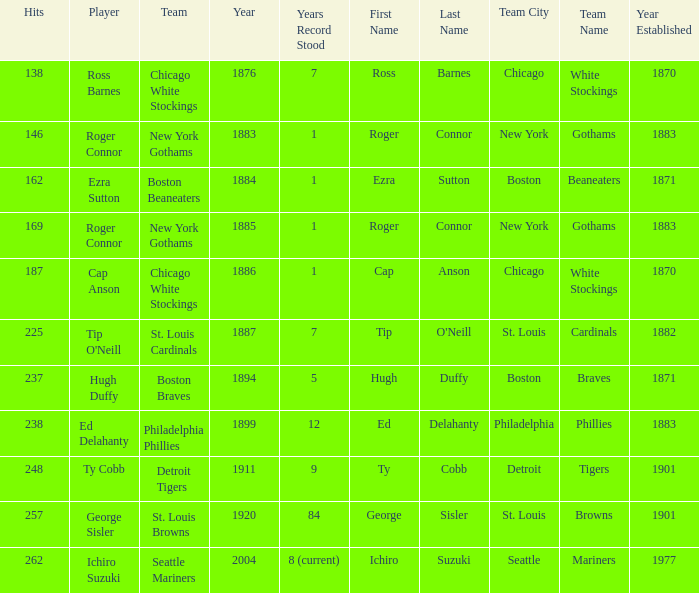In the context of ed delahanty's career, what was the minimum number of hits he achieved in a single year before 1920? 238.0. 